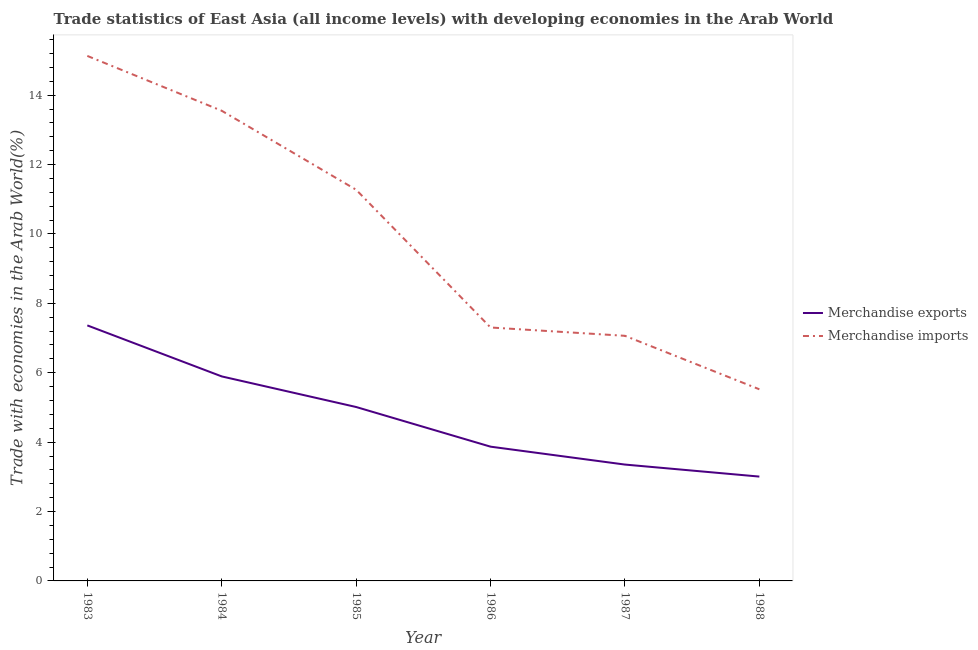Does the line corresponding to merchandise imports intersect with the line corresponding to merchandise exports?
Keep it short and to the point. No. Is the number of lines equal to the number of legend labels?
Give a very brief answer. Yes. What is the merchandise imports in 1984?
Your answer should be very brief. 13.55. Across all years, what is the maximum merchandise exports?
Offer a very short reply. 7.36. Across all years, what is the minimum merchandise exports?
Give a very brief answer. 3.01. In which year was the merchandise exports minimum?
Keep it short and to the point. 1988. What is the total merchandise imports in the graph?
Provide a short and direct response. 59.85. What is the difference between the merchandise exports in 1984 and that in 1985?
Ensure brevity in your answer.  0.88. What is the difference between the merchandise exports in 1983 and the merchandise imports in 1984?
Offer a very short reply. -6.19. What is the average merchandise exports per year?
Keep it short and to the point. 4.75. In the year 1986, what is the difference between the merchandise imports and merchandise exports?
Offer a very short reply. 3.43. In how many years, is the merchandise exports greater than 6.4 %?
Provide a succinct answer. 1. What is the ratio of the merchandise imports in 1983 to that in 1988?
Give a very brief answer. 2.74. Is the merchandise exports in 1986 less than that in 1988?
Your answer should be very brief. No. What is the difference between the highest and the second highest merchandise exports?
Offer a terse response. 1.47. What is the difference between the highest and the lowest merchandise exports?
Your response must be concise. 4.36. Is the sum of the merchandise imports in 1983 and 1987 greater than the maximum merchandise exports across all years?
Provide a short and direct response. Yes. Does the merchandise exports monotonically increase over the years?
Ensure brevity in your answer.  No. What is the difference between two consecutive major ticks on the Y-axis?
Provide a succinct answer. 2. Does the graph contain grids?
Your answer should be very brief. No. How many legend labels are there?
Keep it short and to the point. 2. What is the title of the graph?
Offer a very short reply. Trade statistics of East Asia (all income levels) with developing economies in the Arab World. Does "Netherlands" appear as one of the legend labels in the graph?
Offer a terse response. No. What is the label or title of the Y-axis?
Your answer should be compact. Trade with economies in the Arab World(%). What is the Trade with economies in the Arab World(%) in Merchandise exports in 1983?
Offer a very short reply. 7.36. What is the Trade with economies in the Arab World(%) in Merchandise imports in 1983?
Provide a succinct answer. 15.13. What is the Trade with economies in the Arab World(%) in Merchandise exports in 1984?
Your answer should be compact. 5.89. What is the Trade with economies in the Arab World(%) in Merchandise imports in 1984?
Give a very brief answer. 13.55. What is the Trade with economies in the Arab World(%) in Merchandise exports in 1985?
Provide a short and direct response. 5.01. What is the Trade with economies in the Arab World(%) in Merchandise imports in 1985?
Your answer should be compact. 11.27. What is the Trade with economies in the Arab World(%) in Merchandise exports in 1986?
Offer a terse response. 3.87. What is the Trade with economies in the Arab World(%) of Merchandise imports in 1986?
Your response must be concise. 7.3. What is the Trade with economies in the Arab World(%) in Merchandise exports in 1987?
Give a very brief answer. 3.35. What is the Trade with economies in the Arab World(%) of Merchandise imports in 1987?
Your response must be concise. 7.06. What is the Trade with economies in the Arab World(%) of Merchandise exports in 1988?
Offer a very short reply. 3.01. What is the Trade with economies in the Arab World(%) in Merchandise imports in 1988?
Your answer should be compact. 5.52. Across all years, what is the maximum Trade with economies in the Arab World(%) of Merchandise exports?
Your answer should be compact. 7.36. Across all years, what is the maximum Trade with economies in the Arab World(%) in Merchandise imports?
Provide a short and direct response. 15.13. Across all years, what is the minimum Trade with economies in the Arab World(%) of Merchandise exports?
Make the answer very short. 3.01. Across all years, what is the minimum Trade with economies in the Arab World(%) in Merchandise imports?
Give a very brief answer. 5.52. What is the total Trade with economies in the Arab World(%) of Merchandise exports in the graph?
Provide a short and direct response. 28.5. What is the total Trade with economies in the Arab World(%) of Merchandise imports in the graph?
Make the answer very short. 59.85. What is the difference between the Trade with economies in the Arab World(%) of Merchandise exports in 1983 and that in 1984?
Offer a terse response. 1.47. What is the difference between the Trade with economies in the Arab World(%) in Merchandise imports in 1983 and that in 1984?
Give a very brief answer. 1.58. What is the difference between the Trade with economies in the Arab World(%) in Merchandise exports in 1983 and that in 1985?
Your answer should be very brief. 2.35. What is the difference between the Trade with economies in the Arab World(%) in Merchandise imports in 1983 and that in 1985?
Keep it short and to the point. 3.86. What is the difference between the Trade with economies in the Arab World(%) in Merchandise exports in 1983 and that in 1986?
Keep it short and to the point. 3.5. What is the difference between the Trade with economies in the Arab World(%) of Merchandise imports in 1983 and that in 1986?
Make the answer very short. 7.83. What is the difference between the Trade with economies in the Arab World(%) of Merchandise exports in 1983 and that in 1987?
Your response must be concise. 4.01. What is the difference between the Trade with economies in the Arab World(%) of Merchandise imports in 1983 and that in 1987?
Offer a very short reply. 8.07. What is the difference between the Trade with economies in the Arab World(%) of Merchandise exports in 1983 and that in 1988?
Your answer should be compact. 4.36. What is the difference between the Trade with economies in the Arab World(%) in Merchandise imports in 1983 and that in 1988?
Keep it short and to the point. 9.61. What is the difference between the Trade with economies in the Arab World(%) of Merchandise exports in 1984 and that in 1985?
Offer a terse response. 0.88. What is the difference between the Trade with economies in the Arab World(%) of Merchandise imports in 1984 and that in 1985?
Your response must be concise. 2.28. What is the difference between the Trade with economies in the Arab World(%) in Merchandise exports in 1984 and that in 1986?
Keep it short and to the point. 2.02. What is the difference between the Trade with economies in the Arab World(%) of Merchandise imports in 1984 and that in 1986?
Offer a terse response. 6.25. What is the difference between the Trade with economies in the Arab World(%) of Merchandise exports in 1984 and that in 1987?
Provide a short and direct response. 2.54. What is the difference between the Trade with economies in the Arab World(%) of Merchandise imports in 1984 and that in 1987?
Provide a short and direct response. 6.49. What is the difference between the Trade with economies in the Arab World(%) in Merchandise exports in 1984 and that in 1988?
Your response must be concise. 2.89. What is the difference between the Trade with economies in the Arab World(%) in Merchandise imports in 1984 and that in 1988?
Offer a terse response. 8.03. What is the difference between the Trade with economies in the Arab World(%) of Merchandise imports in 1985 and that in 1986?
Provide a short and direct response. 3.97. What is the difference between the Trade with economies in the Arab World(%) in Merchandise exports in 1985 and that in 1987?
Your answer should be compact. 1.66. What is the difference between the Trade with economies in the Arab World(%) of Merchandise imports in 1985 and that in 1987?
Your answer should be compact. 4.21. What is the difference between the Trade with economies in the Arab World(%) of Merchandise exports in 1985 and that in 1988?
Offer a terse response. 2.01. What is the difference between the Trade with economies in the Arab World(%) of Merchandise imports in 1985 and that in 1988?
Give a very brief answer. 5.75. What is the difference between the Trade with economies in the Arab World(%) in Merchandise exports in 1986 and that in 1987?
Ensure brevity in your answer.  0.52. What is the difference between the Trade with economies in the Arab World(%) of Merchandise imports in 1986 and that in 1987?
Your answer should be compact. 0.24. What is the difference between the Trade with economies in the Arab World(%) of Merchandise exports in 1986 and that in 1988?
Provide a short and direct response. 0.86. What is the difference between the Trade with economies in the Arab World(%) in Merchandise imports in 1986 and that in 1988?
Keep it short and to the point. 1.78. What is the difference between the Trade with economies in the Arab World(%) of Merchandise exports in 1987 and that in 1988?
Offer a terse response. 0.35. What is the difference between the Trade with economies in the Arab World(%) of Merchandise imports in 1987 and that in 1988?
Keep it short and to the point. 1.54. What is the difference between the Trade with economies in the Arab World(%) in Merchandise exports in 1983 and the Trade with economies in the Arab World(%) in Merchandise imports in 1984?
Provide a short and direct response. -6.19. What is the difference between the Trade with economies in the Arab World(%) of Merchandise exports in 1983 and the Trade with economies in the Arab World(%) of Merchandise imports in 1985?
Offer a very short reply. -3.91. What is the difference between the Trade with economies in the Arab World(%) in Merchandise exports in 1983 and the Trade with economies in the Arab World(%) in Merchandise imports in 1986?
Keep it short and to the point. 0.06. What is the difference between the Trade with economies in the Arab World(%) of Merchandise exports in 1983 and the Trade with economies in the Arab World(%) of Merchandise imports in 1987?
Make the answer very short. 0.3. What is the difference between the Trade with economies in the Arab World(%) of Merchandise exports in 1983 and the Trade with economies in the Arab World(%) of Merchandise imports in 1988?
Your answer should be compact. 1.84. What is the difference between the Trade with economies in the Arab World(%) of Merchandise exports in 1984 and the Trade with economies in the Arab World(%) of Merchandise imports in 1985?
Your answer should be compact. -5.38. What is the difference between the Trade with economies in the Arab World(%) in Merchandise exports in 1984 and the Trade with economies in the Arab World(%) in Merchandise imports in 1986?
Provide a succinct answer. -1.41. What is the difference between the Trade with economies in the Arab World(%) in Merchandise exports in 1984 and the Trade with economies in the Arab World(%) in Merchandise imports in 1987?
Provide a succinct answer. -1.17. What is the difference between the Trade with economies in the Arab World(%) of Merchandise exports in 1984 and the Trade with economies in the Arab World(%) of Merchandise imports in 1988?
Keep it short and to the point. 0.37. What is the difference between the Trade with economies in the Arab World(%) in Merchandise exports in 1985 and the Trade with economies in the Arab World(%) in Merchandise imports in 1986?
Your answer should be compact. -2.29. What is the difference between the Trade with economies in the Arab World(%) in Merchandise exports in 1985 and the Trade with economies in the Arab World(%) in Merchandise imports in 1987?
Your response must be concise. -2.05. What is the difference between the Trade with economies in the Arab World(%) in Merchandise exports in 1985 and the Trade with economies in the Arab World(%) in Merchandise imports in 1988?
Give a very brief answer. -0.51. What is the difference between the Trade with economies in the Arab World(%) of Merchandise exports in 1986 and the Trade with economies in the Arab World(%) of Merchandise imports in 1987?
Provide a succinct answer. -3.2. What is the difference between the Trade with economies in the Arab World(%) of Merchandise exports in 1986 and the Trade with economies in the Arab World(%) of Merchandise imports in 1988?
Ensure brevity in your answer.  -1.65. What is the difference between the Trade with economies in the Arab World(%) in Merchandise exports in 1987 and the Trade with economies in the Arab World(%) in Merchandise imports in 1988?
Make the answer very short. -2.17. What is the average Trade with economies in the Arab World(%) of Merchandise exports per year?
Your response must be concise. 4.75. What is the average Trade with economies in the Arab World(%) in Merchandise imports per year?
Ensure brevity in your answer.  9.97. In the year 1983, what is the difference between the Trade with economies in the Arab World(%) in Merchandise exports and Trade with economies in the Arab World(%) in Merchandise imports?
Make the answer very short. -7.77. In the year 1984, what is the difference between the Trade with economies in the Arab World(%) of Merchandise exports and Trade with economies in the Arab World(%) of Merchandise imports?
Ensure brevity in your answer.  -7.66. In the year 1985, what is the difference between the Trade with economies in the Arab World(%) of Merchandise exports and Trade with economies in the Arab World(%) of Merchandise imports?
Give a very brief answer. -6.26. In the year 1986, what is the difference between the Trade with economies in the Arab World(%) in Merchandise exports and Trade with economies in the Arab World(%) in Merchandise imports?
Your answer should be compact. -3.43. In the year 1987, what is the difference between the Trade with economies in the Arab World(%) in Merchandise exports and Trade with economies in the Arab World(%) in Merchandise imports?
Offer a terse response. -3.71. In the year 1988, what is the difference between the Trade with economies in the Arab World(%) in Merchandise exports and Trade with economies in the Arab World(%) in Merchandise imports?
Keep it short and to the point. -2.52. What is the ratio of the Trade with economies in the Arab World(%) in Merchandise exports in 1983 to that in 1984?
Ensure brevity in your answer.  1.25. What is the ratio of the Trade with economies in the Arab World(%) in Merchandise imports in 1983 to that in 1984?
Provide a short and direct response. 1.12. What is the ratio of the Trade with economies in the Arab World(%) in Merchandise exports in 1983 to that in 1985?
Your answer should be very brief. 1.47. What is the ratio of the Trade with economies in the Arab World(%) of Merchandise imports in 1983 to that in 1985?
Give a very brief answer. 1.34. What is the ratio of the Trade with economies in the Arab World(%) in Merchandise exports in 1983 to that in 1986?
Make the answer very short. 1.9. What is the ratio of the Trade with economies in the Arab World(%) of Merchandise imports in 1983 to that in 1986?
Your answer should be very brief. 2.07. What is the ratio of the Trade with economies in the Arab World(%) of Merchandise exports in 1983 to that in 1987?
Offer a very short reply. 2.2. What is the ratio of the Trade with economies in the Arab World(%) of Merchandise imports in 1983 to that in 1987?
Provide a short and direct response. 2.14. What is the ratio of the Trade with economies in the Arab World(%) of Merchandise exports in 1983 to that in 1988?
Make the answer very short. 2.45. What is the ratio of the Trade with economies in the Arab World(%) in Merchandise imports in 1983 to that in 1988?
Provide a succinct answer. 2.74. What is the ratio of the Trade with economies in the Arab World(%) in Merchandise exports in 1984 to that in 1985?
Ensure brevity in your answer.  1.18. What is the ratio of the Trade with economies in the Arab World(%) of Merchandise imports in 1984 to that in 1985?
Provide a short and direct response. 1.2. What is the ratio of the Trade with economies in the Arab World(%) of Merchandise exports in 1984 to that in 1986?
Keep it short and to the point. 1.52. What is the ratio of the Trade with economies in the Arab World(%) of Merchandise imports in 1984 to that in 1986?
Offer a terse response. 1.86. What is the ratio of the Trade with economies in the Arab World(%) of Merchandise exports in 1984 to that in 1987?
Provide a short and direct response. 1.76. What is the ratio of the Trade with economies in the Arab World(%) in Merchandise imports in 1984 to that in 1987?
Provide a succinct answer. 1.92. What is the ratio of the Trade with economies in the Arab World(%) of Merchandise exports in 1984 to that in 1988?
Your response must be concise. 1.96. What is the ratio of the Trade with economies in the Arab World(%) of Merchandise imports in 1984 to that in 1988?
Ensure brevity in your answer.  2.45. What is the ratio of the Trade with economies in the Arab World(%) of Merchandise exports in 1985 to that in 1986?
Give a very brief answer. 1.3. What is the ratio of the Trade with economies in the Arab World(%) of Merchandise imports in 1985 to that in 1986?
Your answer should be very brief. 1.54. What is the ratio of the Trade with economies in the Arab World(%) of Merchandise exports in 1985 to that in 1987?
Your answer should be compact. 1.49. What is the ratio of the Trade with economies in the Arab World(%) in Merchandise imports in 1985 to that in 1987?
Offer a very short reply. 1.6. What is the ratio of the Trade with economies in the Arab World(%) in Merchandise exports in 1985 to that in 1988?
Your answer should be very brief. 1.67. What is the ratio of the Trade with economies in the Arab World(%) in Merchandise imports in 1985 to that in 1988?
Keep it short and to the point. 2.04. What is the ratio of the Trade with economies in the Arab World(%) in Merchandise exports in 1986 to that in 1987?
Offer a terse response. 1.15. What is the ratio of the Trade with economies in the Arab World(%) in Merchandise imports in 1986 to that in 1987?
Your answer should be compact. 1.03. What is the ratio of the Trade with economies in the Arab World(%) in Merchandise exports in 1986 to that in 1988?
Make the answer very short. 1.29. What is the ratio of the Trade with economies in the Arab World(%) in Merchandise imports in 1986 to that in 1988?
Give a very brief answer. 1.32. What is the ratio of the Trade with economies in the Arab World(%) of Merchandise exports in 1987 to that in 1988?
Your response must be concise. 1.12. What is the ratio of the Trade with economies in the Arab World(%) of Merchandise imports in 1987 to that in 1988?
Provide a succinct answer. 1.28. What is the difference between the highest and the second highest Trade with economies in the Arab World(%) of Merchandise exports?
Provide a succinct answer. 1.47. What is the difference between the highest and the second highest Trade with economies in the Arab World(%) of Merchandise imports?
Offer a very short reply. 1.58. What is the difference between the highest and the lowest Trade with economies in the Arab World(%) of Merchandise exports?
Provide a succinct answer. 4.36. What is the difference between the highest and the lowest Trade with economies in the Arab World(%) of Merchandise imports?
Provide a succinct answer. 9.61. 